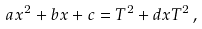Convert formula to latex. <formula><loc_0><loc_0><loc_500><loc_500>a x ^ { 2 } + b x + c = T ^ { 2 } + d x T ^ { 2 } \, ,</formula> 